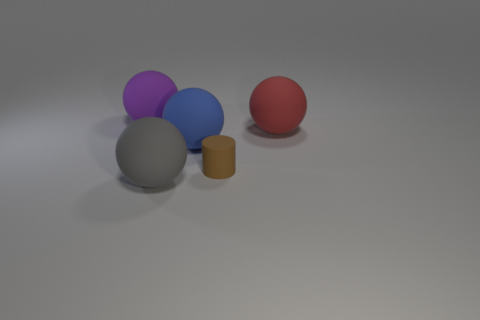Subtract all big purple matte balls. How many balls are left? 3 Subtract all purple spheres. How many spheres are left? 3 Subtract all cylinders. How many objects are left? 4 Subtract 1 cylinders. How many cylinders are left? 0 Subtract all blue spheres. Subtract all brown cylinders. How many spheres are left? 3 Subtract all cyan balls. How many green cylinders are left? 0 Subtract all large yellow metal things. Subtract all tiny brown rubber things. How many objects are left? 4 Add 3 large red balls. How many large red balls are left? 4 Add 4 large gray matte cylinders. How many large gray matte cylinders exist? 4 Add 1 tiny brown metallic cylinders. How many objects exist? 6 